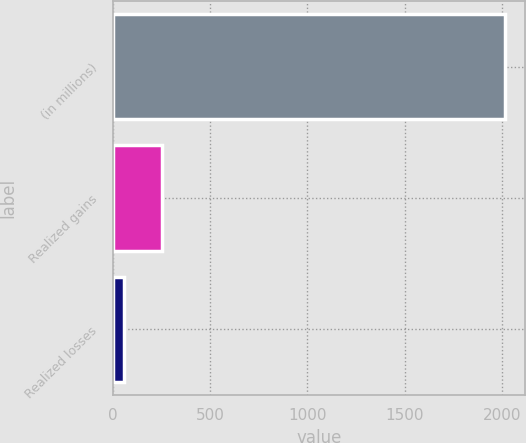<chart> <loc_0><loc_0><loc_500><loc_500><bar_chart><fcel>(in millions)<fcel>Realized gains<fcel>Realized losses<nl><fcel>2016<fcel>251.1<fcel>55<nl></chart> 